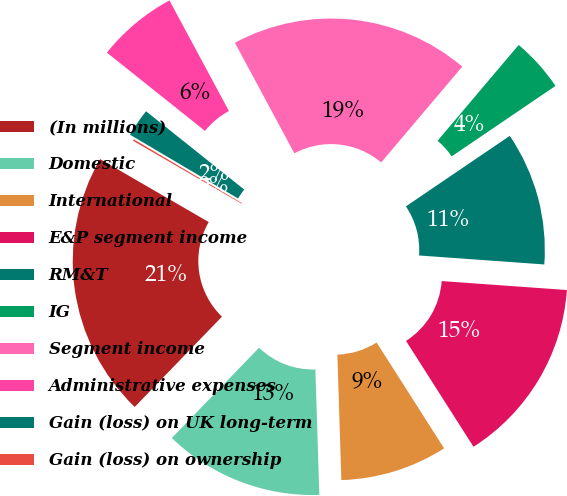<chart> <loc_0><loc_0><loc_500><loc_500><pie_chart><fcel>(In millions)<fcel>Domestic<fcel>International<fcel>E&P segment income<fcel>RM&T<fcel>IG<fcel>Segment income<fcel>Administrative expenses<fcel>Gain (loss) on UK long-term<fcel>Gain (loss) on ownership<nl><fcel>21.13%<fcel>12.73%<fcel>8.53%<fcel>14.83%<fcel>10.63%<fcel>4.33%<fcel>19.03%<fcel>6.43%<fcel>2.23%<fcel>0.13%<nl></chart> 